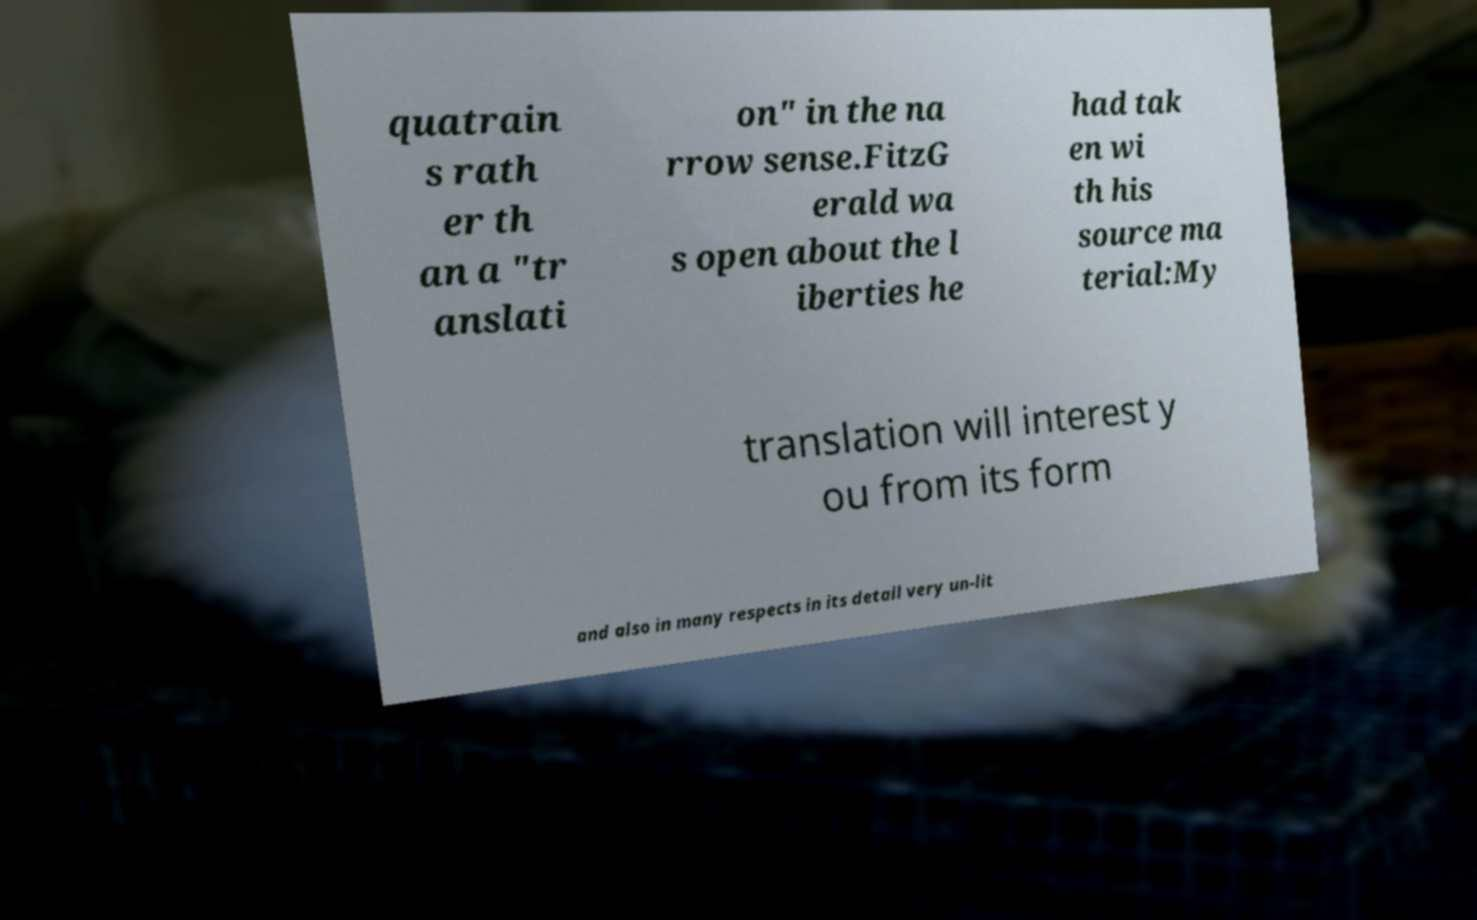What messages or text are displayed in this image? I need them in a readable, typed format. quatrain s rath er th an a "tr anslati on" in the na rrow sense.FitzG erald wa s open about the l iberties he had tak en wi th his source ma terial:My translation will interest y ou from its form and also in many respects in its detail very un-lit 